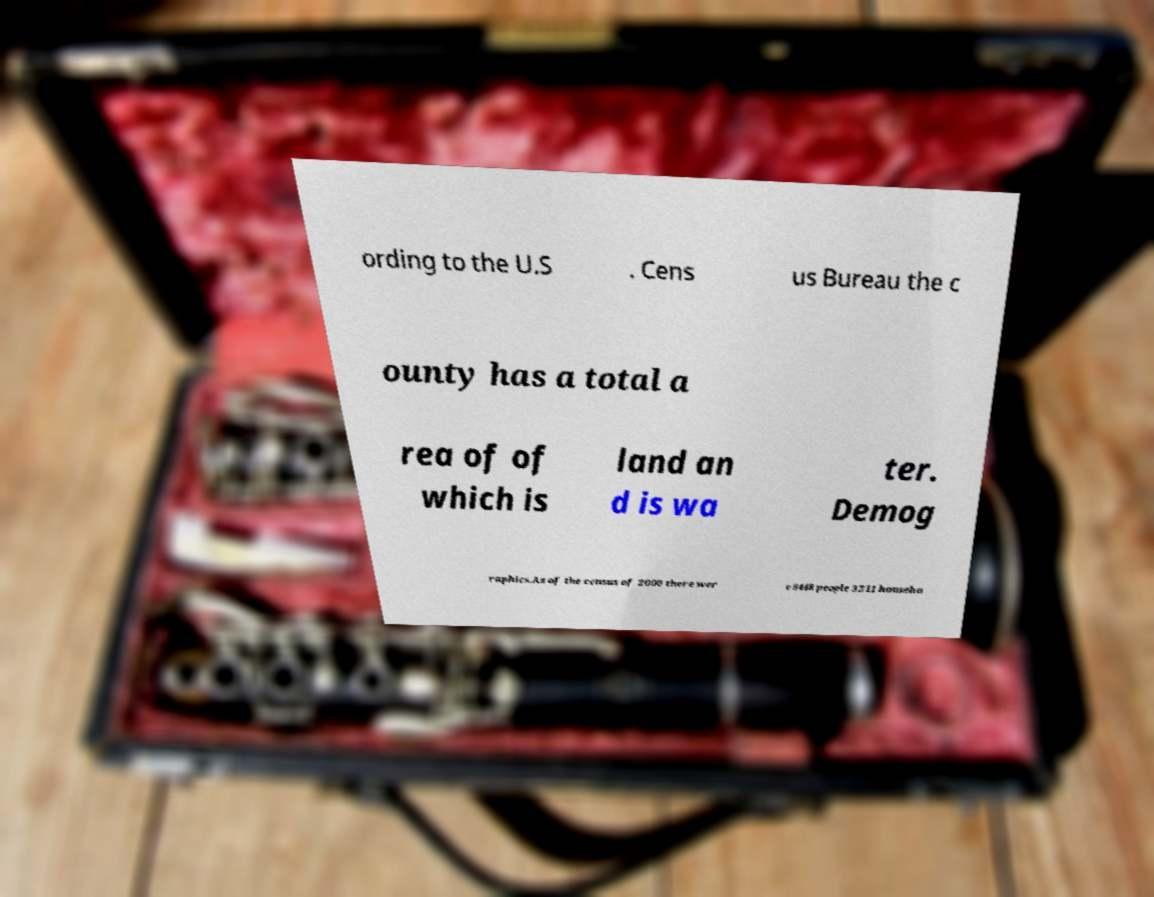Please read and relay the text visible in this image. What does it say? ording to the U.S . Cens us Bureau the c ounty has a total a rea of of which is land an d is wa ter. Demog raphics.As of the census of 2000 there wer e 8448 people 3211 househo 